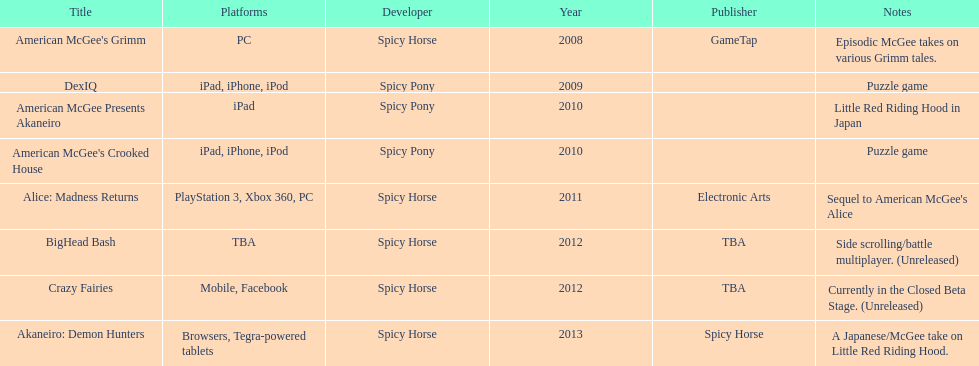What year had a total of 2 titles released? 2010. 